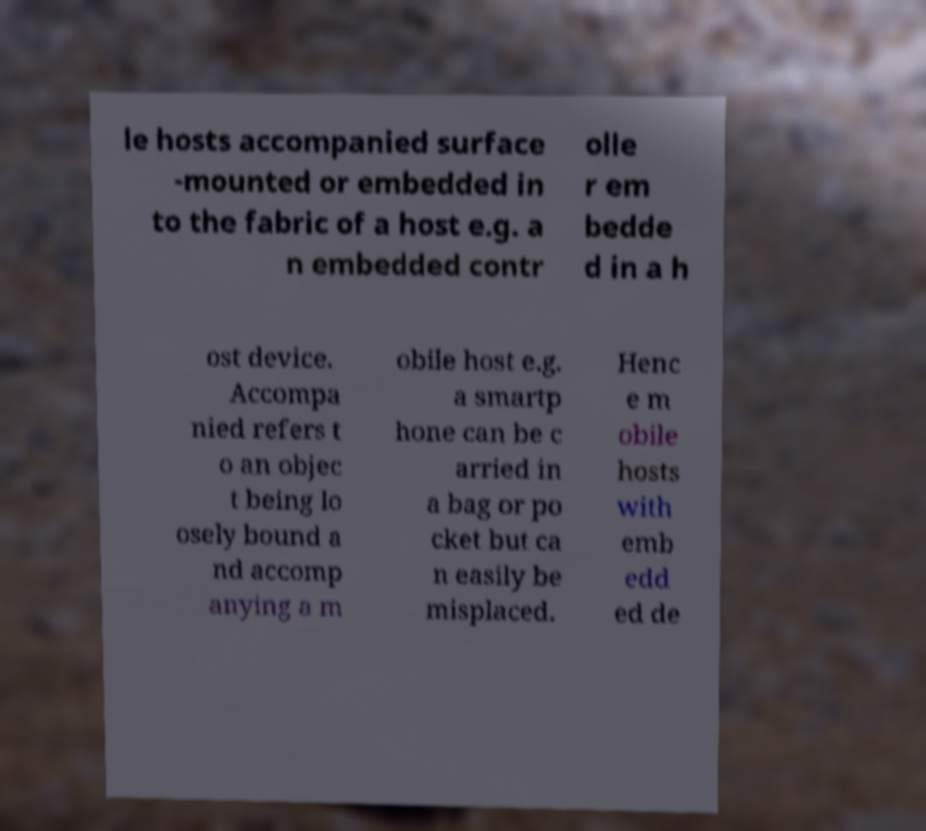Can you read and provide the text displayed in the image?This photo seems to have some interesting text. Can you extract and type it out for me? le hosts accompanied surface -mounted or embedded in to the fabric of a host e.g. a n embedded contr olle r em bedde d in a h ost device. Accompa nied refers t o an objec t being lo osely bound a nd accomp anying a m obile host e.g. a smartp hone can be c arried in a bag or po cket but ca n easily be misplaced. Henc e m obile hosts with emb edd ed de 